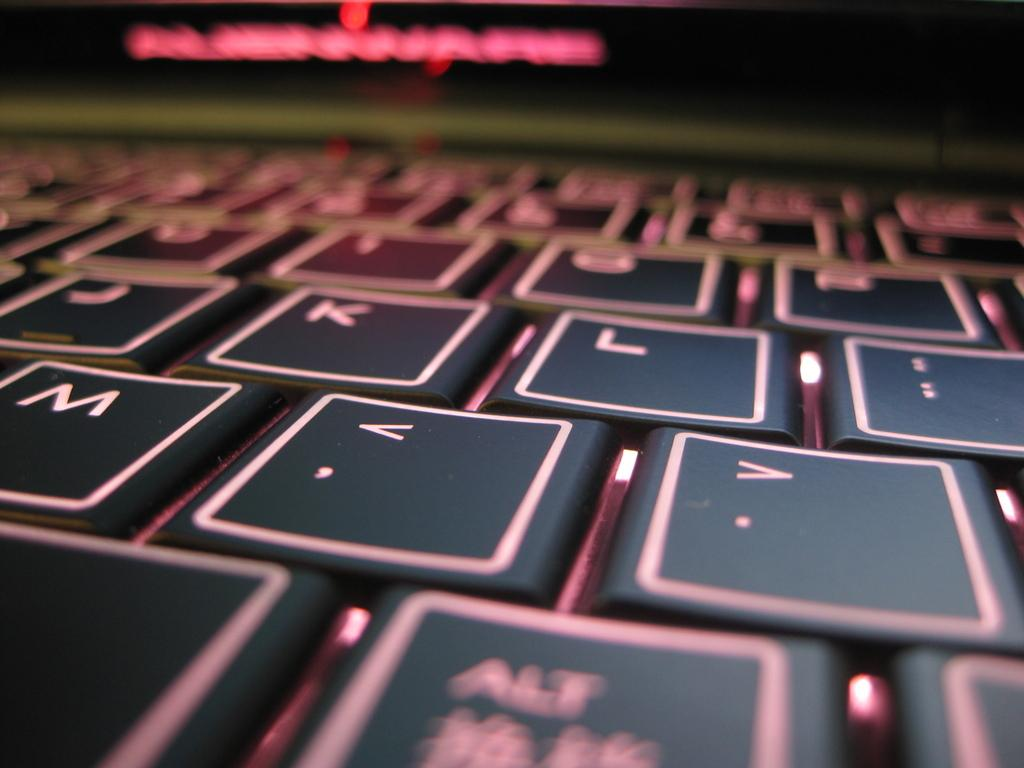<image>
Write a terse but informative summary of the picture. Red and black keyboard with the K key between the J and L key. 